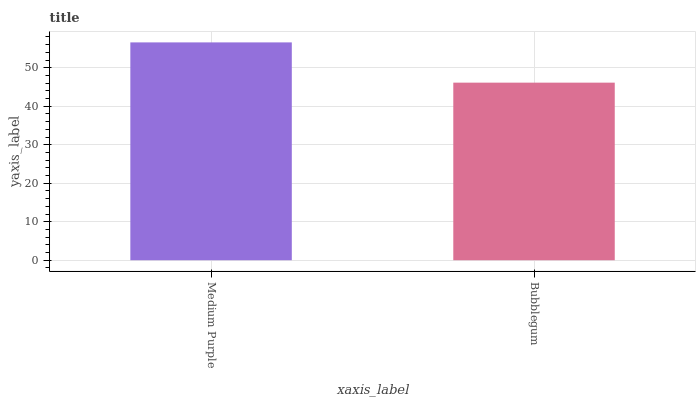Is Bubblegum the minimum?
Answer yes or no. Yes. Is Medium Purple the maximum?
Answer yes or no. Yes. Is Bubblegum the maximum?
Answer yes or no. No. Is Medium Purple greater than Bubblegum?
Answer yes or no. Yes. Is Bubblegum less than Medium Purple?
Answer yes or no. Yes. Is Bubblegum greater than Medium Purple?
Answer yes or no. No. Is Medium Purple less than Bubblegum?
Answer yes or no. No. Is Medium Purple the high median?
Answer yes or no. Yes. Is Bubblegum the low median?
Answer yes or no. Yes. Is Bubblegum the high median?
Answer yes or no. No. Is Medium Purple the low median?
Answer yes or no. No. 